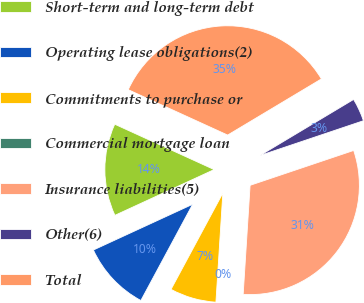Convert chart to OTSL. <chart><loc_0><loc_0><loc_500><loc_500><pie_chart><fcel>Short-term and long-term debt<fcel>Operating lease obligations(2)<fcel>Commitments to purchase or<fcel>Commercial mortgage loan<fcel>Insurance liabilities(5)<fcel>Other(6)<fcel>Total<nl><fcel>13.69%<fcel>10.27%<fcel>6.85%<fcel>0.0%<fcel>31.18%<fcel>3.42%<fcel>34.6%<nl></chart> 